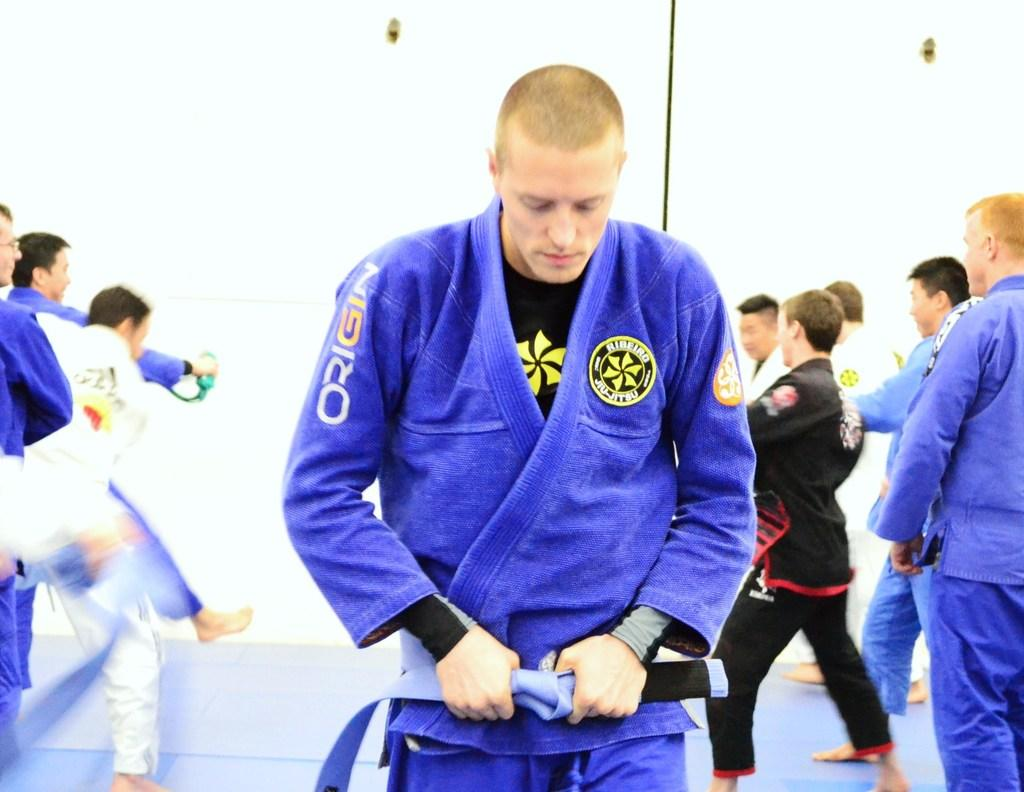<image>
Render a clear and concise summary of the photo. A group of men are practicing karate and their uniforms say Origin. 